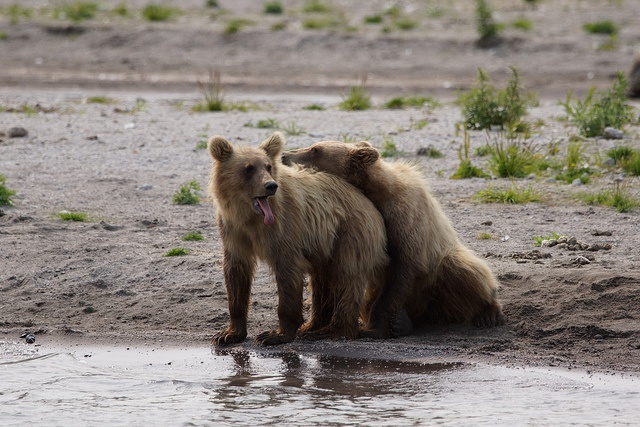Describe the objects in this image and their specific colors. I can see bear in darkgray, black, gray, and maroon tones and bear in darkgray, black, and gray tones in this image. 